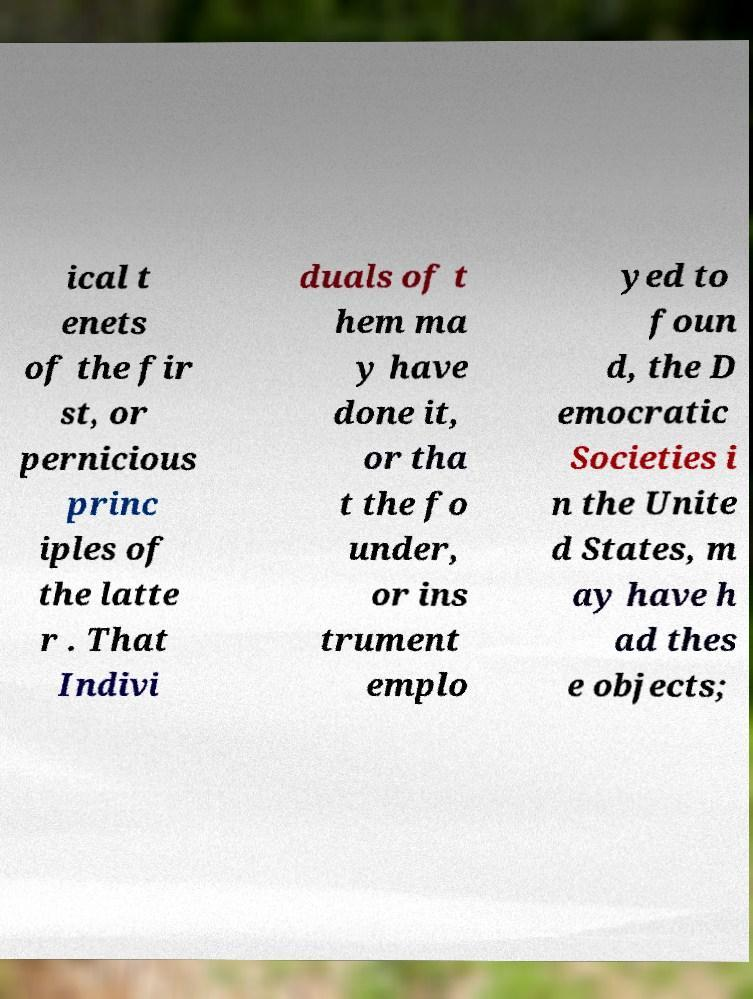There's text embedded in this image that I need extracted. Can you transcribe it verbatim? ical t enets of the fir st, or pernicious princ iples of the latte r . That Indivi duals of t hem ma y have done it, or tha t the fo under, or ins trument emplo yed to foun d, the D emocratic Societies i n the Unite d States, m ay have h ad thes e objects; 